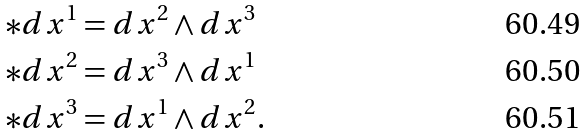Convert formula to latex. <formula><loc_0><loc_0><loc_500><loc_500>* d x ^ { 1 } & = d x ^ { 2 } \wedge d x ^ { 3 } \\ * d x ^ { 2 } & = d x ^ { 3 } \wedge d x ^ { 1 } \\ * d x ^ { 3 } & = d x ^ { 1 } \wedge d x ^ { 2 } .</formula> 